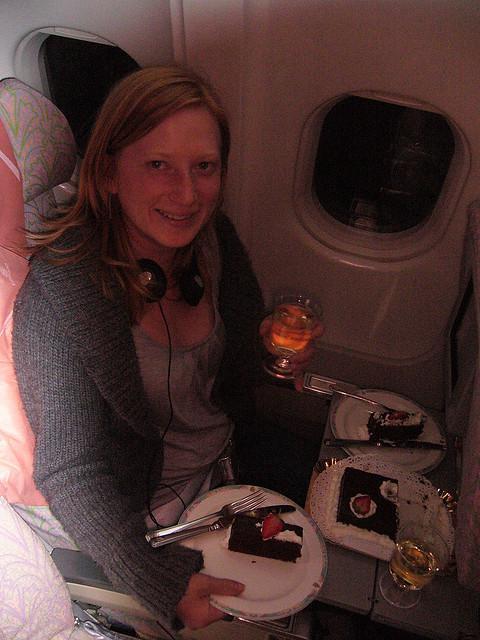Where is this woman feasting?
Indicate the correct response by choosing from the four available options to answer the question.
Options: Airplane, train, subway, bus. Airplane. 